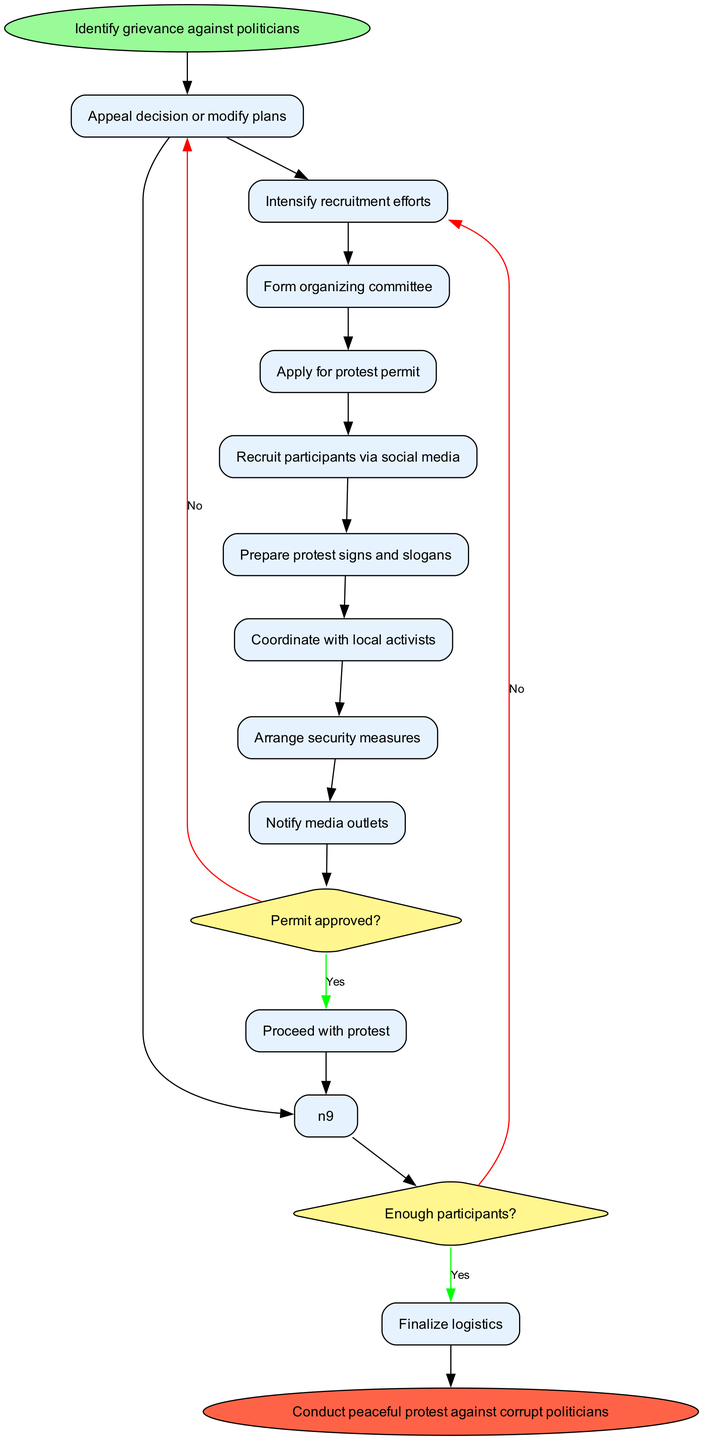What is the first step in organizing a protest? The diagram starts with the node labeled "Identify grievance against politicians," which is the first step in the flow.
Answer: Identify grievance against politicians How many nodes are there in the protest organization process? The flow chart includes ten nodes: one start node, eight process nodes, and one end node.
Answer: Ten What is the condition for the decision node that follows the "Apply for protest permit" step? The decision node that follows "Apply for protest permit" is labeled "Permit approved?" which indicates it is the first decision point after that step.
Answer: Permit approved? What happens if the permit is denied? If the permit is denied, the flow indicates to "Appeal decision or modify plans," which is the path taken if the answer to the "Permit approved?" question is "No."
Answer: Appeal decision or modify plans What action is taken if there are not enough participants? If there are not enough participants, the flow instructs to "Intensify recruitment efforts," which is the course of action that follows if the answer to the "Enough participants?" question is "No."
Answer: Intensify recruitment efforts How does the process conclude? The flow chart concludes with the end node labeled "Conduct peaceful protest against corrupt politicians," indicating the final outcome of the organizing process.
Answer: Conduct peaceful protest against corrupt politicians What should be done before finalizing logistics? Before finalizing logistics, the condition checking for "Enough participants?" must yield a "Yes," allowing the flow to go to "Finalize logistics."
Answer: Finalize logistics What is one way to recruit participants? One method for recruitment mentioned in the nodes is "Recruit participants via social media," which is specifically listed in the process.
Answer: Recruit participants via social media What is the flow after the decision "Enough participants?" if the answer is "Yes"? If the answer is "Yes" to "Enough participants?", the flow proceeds to "Finalize logistics," which indicates that the preparation can continue.
Answer: Finalize logistics 